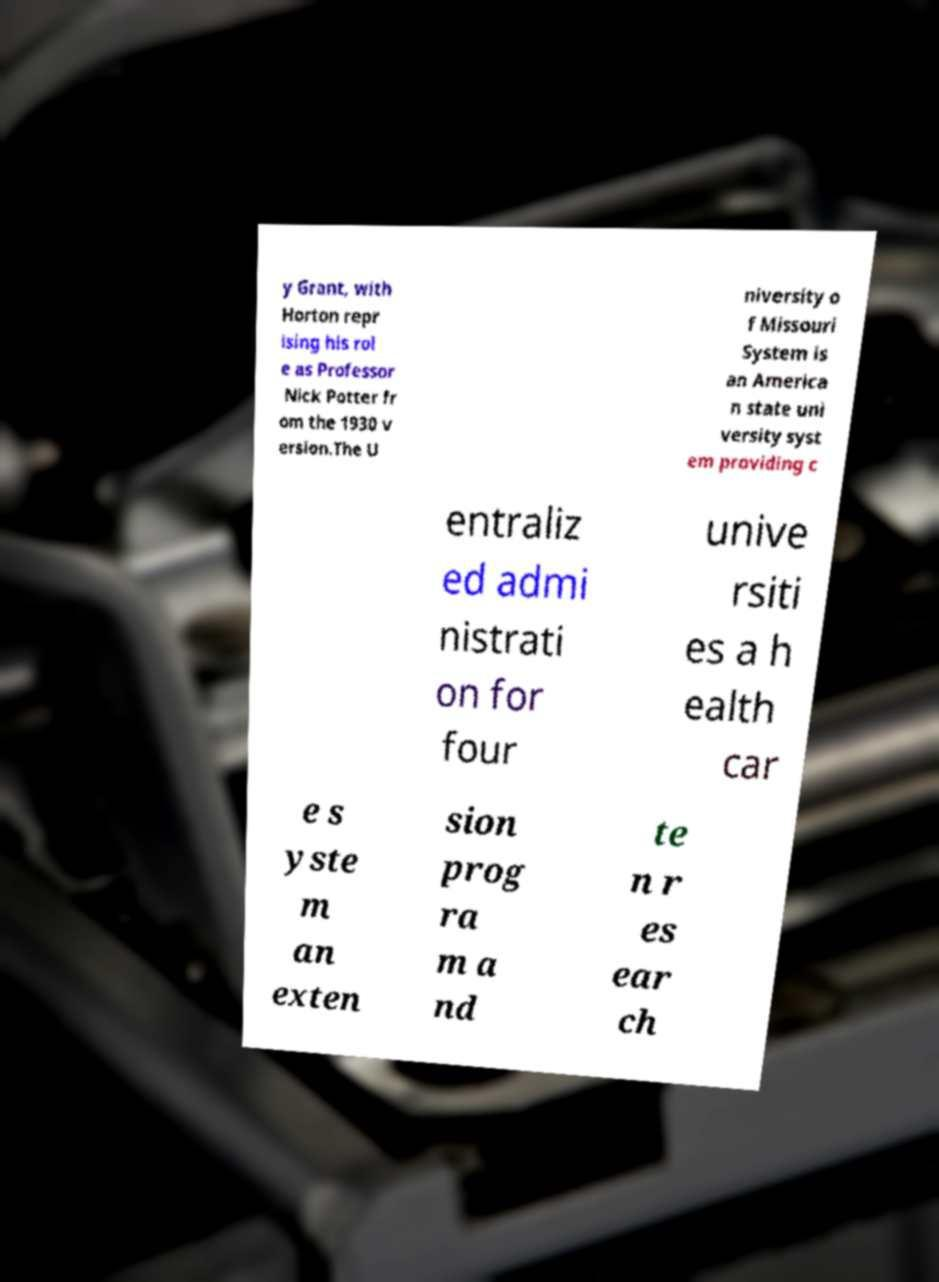Could you extract and type out the text from this image? y Grant, with Horton repr ising his rol e as Professor Nick Potter fr om the 1930 v ersion.The U niversity o f Missouri System is an America n state uni versity syst em providing c entraliz ed admi nistrati on for four unive rsiti es a h ealth car e s yste m an exten sion prog ra m a nd te n r es ear ch 